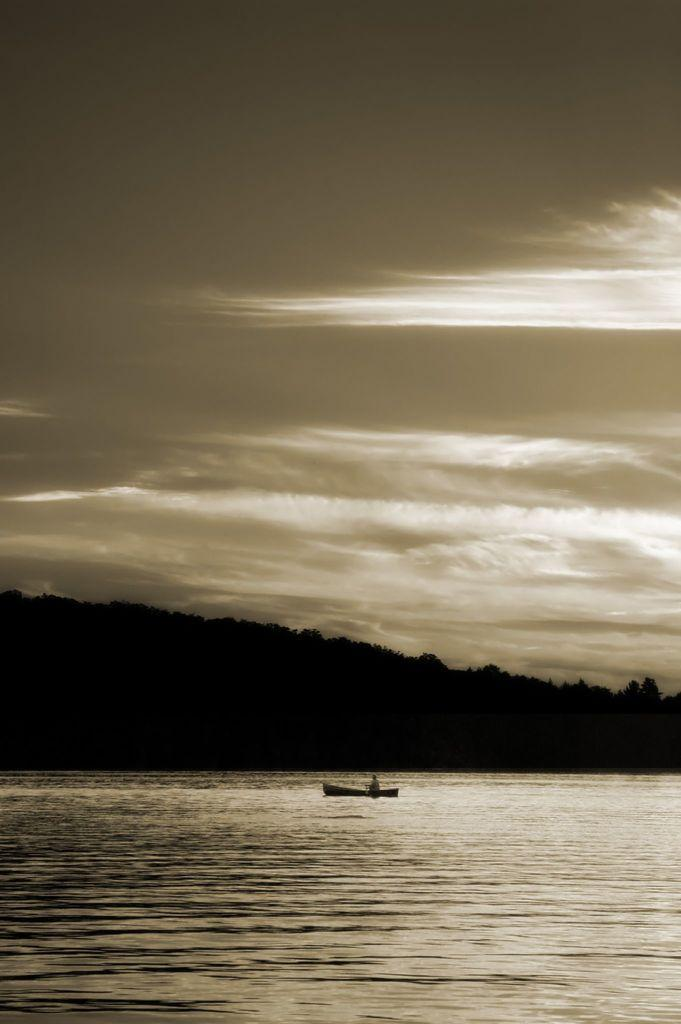What is the main feature of the image? There is water in the image. What is floating on the water? There is a boat in the water. Who is in the boat? There is a person in the boat. What can be seen in the background of the image? There are trees and a mountain visible in the image. What is visible at the top of the image? The sky is visible at the top of the image. What type of smell can be detected coming from the water in the image? There is no indication of any smell in the image, as it is a visual representation. 